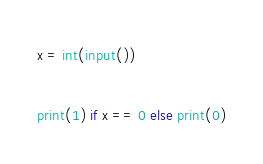<code> <loc_0><loc_0><loc_500><loc_500><_Python_>x = int(input())

print(1) if x == 0 else print(0)</code> 